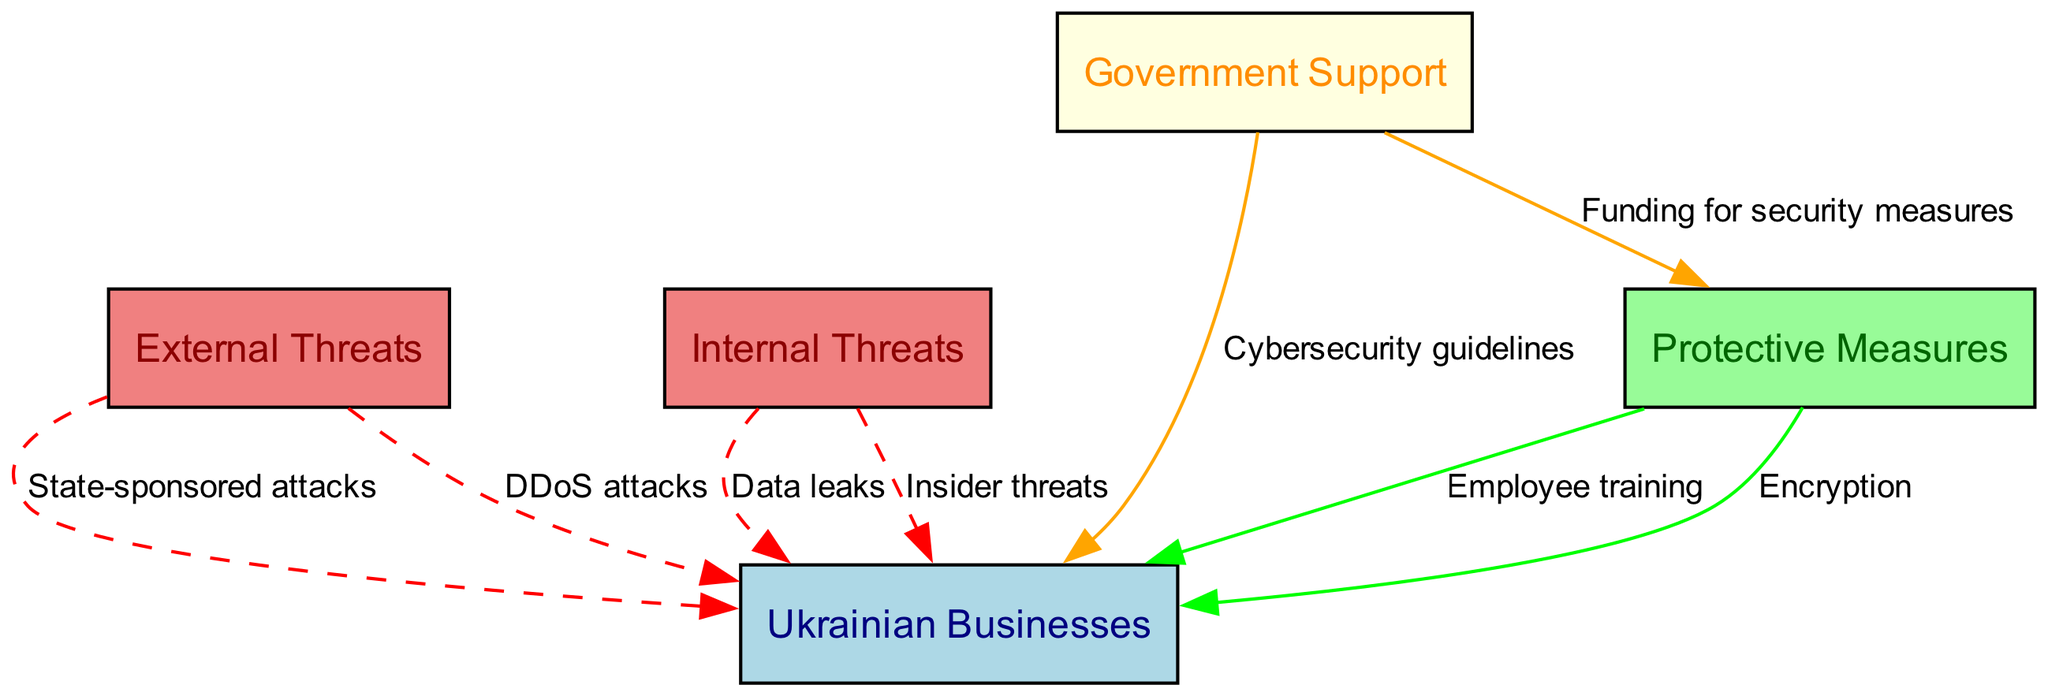What are the two types of threats depicted in the diagram? The diagram shows two types of threats: "External Threats" and "Internal Threats," which are categorized according to their origin.
Answer: External Threats, Internal Threats How many protective measures are listed in the diagram? The diagram lists three protective measures: "Employee training," "Encryption," and the government initiatives under "Government Support." Hence, there are three distinct measures represented.
Answer: 3 What type of attack is labeled as a state-sponsored attack? The diagram illustrates that "State-sponsored attacks" is an external threat directed at "Ukrainian Businesses," indicating that these attacks come from state actors outside of Ukraine.
Answer: State-sponsored attacks Which node indicates funding for security measures? In the diagram, "Funding for security measures" is indicated as an edge from the "Government Support" node pointing towards the "Protective Measures" node, specifying a support relationship.
Answer: Government Support What is one example of an internal threat shown in the diagram? The internal threats are "Data leaks" and "Insider threats." In the context, these are presented under the "Internal Threats" node leading to "Ukrainian Businesses."
Answer: Data leaks Which node is the target of DDoS attacks? The "Ukrainian Businesses" node is the target of "DDoS attacks," as shown by the direct edge connecting these two nodes in the diagram.
Answer: Ukrainian Businesses How many edges are connecting to the "Ukrainian Businesses" node? There are a total of five edges connecting to the "Ukrainian Businesses" node, representing various threats and protective measures directed at it from the other nodes.
Answer: 5 What is one protective measure related to the government? "Cybersecurity guidelines" is a protective measure outlined in the diagram that connects from "Government Support" to "Ukrainian Businesses." This indicates government-backed measures against cyber threats.
Answer: Cybersecurity guidelines What color represents the "Protective Measures" node in the diagram? The "Protective Measures" node is represented in pale green, distinguishing it visually from other nodes, which are colored differently for clarity.
Answer: Pale green 